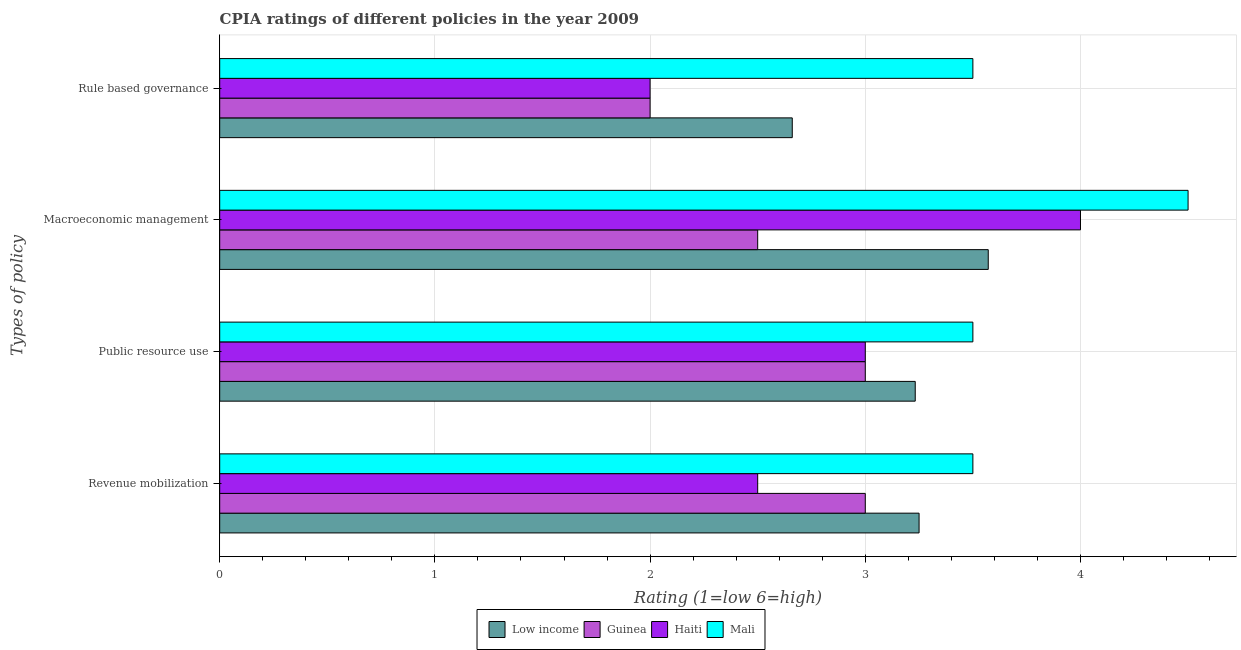How many different coloured bars are there?
Provide a succinct answer. 4. How many bars are there on the 3rd tick from the top?
Give a very brief answer. 4. What is the label of the 2nd group of bars from the top?
Offer a terse response. Macroeconomic management. What is the cpia rating of public resource use in Haiti?
Offer a very short reply. 3. Across all countries, what is the maximum cpia rating of public resource use?
Give a very brief answer. 3.5. Across all countries, what is the minimum cpia rating of public resource use?
Your answer should be compact. 3. In which country was the cpia rating of public resource use maximum?
Provide a succinct answer. Mali. In which country was the cpia rating of public resource use minimum?
Give a very brief answer. Guinea. What is the total cpia rating of rule based governance in the graph?
Offer a terse response. 10.16. What is the difference between the cpia rating of macroeconomic management in Mali and that in Low income?
Provide a succinct answer. 0.93. What is the difference between the cpia rating of public resource use in Low income and the cpia rating of rule based governance in Haiti?
Keep it short and to the point. 1.23. What is the average cpia rating of rule based governance per country?
Your response must be concise. 2.54. What is the difference between the cpia rating of public resource use and cpia rating of revenue mobilization in Low income?
Offer a very short reply. -0.02. In how many countries, is the cpia rating of revenue mobilization greater than 0.6000000000000001 ?
Make the answer very short. 4. What is the ratio of the cpia rating of revenue mobilization in Low income to that in Guinea?
Provide a short and direct response. 1.08. Is the difference between the cpia rating of rule based governance in Guinea and Mali greater than the difference between the cpia rating of revenue mobilization in Guinea and Mali?
Provide a short and direct response. No. What is the difference between the highest and the second highest cpia rating of rule based governance?
Make the answer very short. 0.84. Is it the case that in every country, the sum of the cpia rating of rule based governance and cpia rating of revenue mobilization is greater than the sum of cpia rating of macroeconomic management and cpia rating of public resource use?
Your response must be concise. No. What does the 2nd bar from the top in Rule based governance represents?
Offer a terse response. Haiti. What does the 3rd bar from the bottom in Public resource use represents?
Offer a very short reply. Haiti. Is it the case that in every country, the sum of the cpia rating of revenue mobilization and cpia rating of public resource use is greater than the cpia rating of macroeconomic management?
Provide a succinct answer. Yes. How many bars are there?
Give a very brief answer. 16. What is the difference between two consecutive major ticks on the X-axis?
Keep it short and to the point. 1. Are the values on the major ticks of X-axis written in scientific E-notation?
Offer a terse response. No. Does the graph contain grids?
Offer a terse response. Yes. How many legend labels are there?
Make the answer very short. 4. How are the legend labels stacked?
Keep it short and to the point. Horizontal. What is the title of the graph?
Offer a very short reply. CPIA ratings of different policies in the year 2009. What is the label or title of the Y-axis?
Offer a terse response. Types of policy. What is the Rating (1=low 6=high) in Haiti in Revenue mobilization?
Offer a terse response. 2.5. What is the Rating (1=low 6=high) of Mali in Revenue mobilization?
Ensure brevity in your answer.  3.5. What is the Rating (1=low 6=high) in Low income in Public resource use?
Offer a terse response. 3.23. What is the Rating (1=low 6=high) in Haiti in Public resource use?
Keep it short and to the point. 3. What is the Rating (1=low 6=high) of Low income in Macroeconomic management?
Give a very brief answer. 3.57. What is the Rating (1=low 6=high) in Guinea in Macroeconomic management?
Your response must be concise. 2.5. What is the Rating (1=low 6=high) in Haiti in Macroeconomic management?
Your answer should be very brief. 4. What is the Rating (1=low 6=high) of Mali in Macroeconomic management?
Make the answer very short. 4.5. What is the Rating (1=low 6=high) in Low income in Rule based governance?
Ensure brevity in your answer.  2.66. Across all Types of policy, what is the maximum Rating (1=low 6=high) in Low income?
Offer a terse response. 3.57. Across all Types of policy, what is the maximum Rating (1=low 6=high) in Guinea?
Provide a succinct answer. 3. Across all Types of policy, what is the maximum Rating (1=low 6=high) of Haiti?
Provide a short and direct response. 4. Across all Types of policy, what is the minimum Rating (1=low 6=high) in Low income?
Your answer should be compact. 2.66. Across all Types of policy, what is the minimum Rating (1=low 6=high) of Haiti?
Ensure brevity in your answer.  2. What is the total Rating (1=low 6=high) in Low income in the graph?
Provide a short and direct response. 12.71. What is the total Rating (1=low 6=high) in Haiti in the graph?
Ensure brevity in your answer.  11.5. What is the total Rating (1=low 6=high) in Mali in the graph?
Make the answer very short. 15. What is the difference between the Rating (1=low 6=high) in Low income in Revenue mobilization and that in Public resource use?
Offer a very short reply. 0.02. What is the difference between the Rating (1=low 6=high) of Mali in Revenue mobilization and that in Public resource use?
Your answer should be very brief. 0. What is the difference between the Rating (1=low 6=high) of Low income in Revenue mobilization and that in Macroeconomic management?
Ensure brevity in your answer.  -0.32. What is the difference between the Rating (1=low 6=high) of Guinea in Revenue mobilization and that in Macroeconomic management?
Provide a succinct answer. 0.5. What is the difference between the Rating (1=low 6=high) of Haiti in Revenue mobilization and that in Macroeconomic management?
Ensure brevity in your answer.  -1.5. What is the difference between the Rating (1=low 6=high) of Low income in Revenue mobilization and that in Rule based governance?
Give a very brief answer. 0.59. What is the difference between the Rating (1=low 6=high) in Mali in Revenue mobilization and that in Rule based governance?
Your answer should be very brief. 0. What is the difference between the Rating (1=low 6=high) of Low income in Public resource use and that in Macroeconomic management?
Provide a succinct answer. -0.34. What is the difference between the Rating (1=low 6=high) in Haiti in Public resource use and that in Macroeconomic management?
Ensure brevity in your answer.  -1. What is the difference between the Rating (1=low 6=high) in Mali in Public resource use and that in Macroeconomic management?
Your response must be concise. -1. What is the difference between the Rating (1=low 6=high) in Low income in Public resource use and that in Rule based governance?
Offer a terse response. 0.57. What is the difference between the Rating (1=low 6=high) in Haiti in Public resource use and that in Rule based governance?
Ensure brevity in your answer.  1. What is the difference between the Rating (1=low 6=high) in Low income in Macroeconomic management and that in Rule based governance?
Your answer should be compact. 0.91. What is the difference between the Rating (1=low 6=high) in Guinea in Macroeconomic management and that in Rule based governance?
Provide a succinct answer. 0.5. What is the difference between the Rating (1=low 6=high) in Low income in Revenue mobilization and the Rating (1=low 6=high) in Haiti in Public resource use?
Your response must be concise. 0.25. What is the difference between the Rating (1=low 6=high) in Low income in Revenue mobilization and the Rating (1=low 6=high) in Mali in Public resource use?
Your answer should be compact. -0.25. What is the difference between the Rating (1=low 6=high) in Guinea in Revenue mobilization and the Rating (1=low 6=high) in Mali in Public resource use?
Your response must be concise. -0.5. What is the difference between the Rating (1=low 6=high) in Low income in Revenue mobilization and the Rating (1=low 6=high) in Haiti in Macroeconomic management?
Ensure brevity in your answer.  -0.75. What is the difference between the Rating (1=low 6=high) of Low income in Revenue mobilization and the Rating (1=low 6=high) of Mali in Macroeconomic management?
Keep it short and to the point. -1.25. What is the difference between the Rating (1=low 6=high) of Low income in Revenue mobilization and the Rating (1=low 6=high) of Guinea in Rule based governance?
Your response must be concise. 1.25. What is the difference between the Rating (1=low 6=high) of Low income in Revenue mobilization and the Rating (1=low 6=high) of Haiti in Rule based governance?
Keep it short and to the point. 1.25. What is the difference between the Rating (1=low 6=high) in Guinea in Revenue mobilization and the Rating (1=low 6=high) in Mali in Rule based governance?
Ensure brevity in your answer.  -0.5. What is the difference between the Rating (1=low 6=high) in Low income in Public resource use and the Rating (1=low 6=high) in Guinea in Macroeconomic management?
Offer a terse response. 0.73. What is the difference between the Rating (1=low 6=high) in Low income in Public resource use and the Rating (1=low 6=high) in Haiti in Macroeconomic management?
Your answer should be very brief. -0.77. What is the difference between the Rating (1=low 6=high) of Low income in Public resource use and the Rating (1=low 6=high) of Mali in Macroeconomic management?
Offer a very short reply. -1.27. What is the difference between the Rating (1=low 6=high) in Low income in Public resource use and the Rating (1=low 6=high) in Guinea in Rule based governance?
Give a very brief answer. 1.23. What is the difference between the Rating (1=low 6=high) of Low income in Public resource use and the Rating (1=low 6=high) of Haiti in Rule based governance?
Ensure brevity in your answer.  1.23. What is the difference between the Rating (1=low 6=high) of Low income in Public resource use and the Rating (1=low 6=high) of Mali in Rule based governance?
Make the answer very short. -0.27. What is the difference between the Rating (1=low 6=high) of Guinea in Public resource use and the Rating (1=low 6=high) of Haiti in Rule based governance?
Offer a terse response. 1. What is the difference between the Rating (1=low 6=high) of Haiti in Public resource use and the Rating (1=low 6=high) of Mali in Rule based governance?
Your answer should be very brief. -0.5. What is the difference between the Rating (1=low 6=high) of Low income in Macroeconomic management and the Rating (1=low 6=high) of Guinea in Rule based governance?
Offer a very short reply. 1.57. What is the difference between the Rating (1=low 6=high) of Low income in Macroeconomic management and the Rating (1=low 6=high) of Haiti in Rule based governance?
Make the answer very short. 1.57. What is the difference between the Rating (1=low 6=high) in Low income in Macroeconomic management and the Rating (1=low 6=high) in Mali in Rule based governance?
Keep it short and to the point. 0.07. What is the difference between the Rating (1=low 6=high) of Guinea in Macroeconomic management and the Rating (1=low 6=high) of Haiti in Rule based governance?
Make the answer very short. 0.5. What is the difference between the Rating (1=low 6=high) of Guinea in Macroeconomic management and the Rating (1=low 6=high) of Mali in Rule based governance?
Keep it short and to the point. -1. What is the average Rating (1=low 6=high) in Low income per Types of policy?
Keep it short and to the point. 3.18. What is the average Rating (1=low 6=high) of Guinea per Types of policy?
Provide a succinct answer. 2.62. What is the average Rating (1=low 6=high) in Haiti per Types of policy?
Your response must be concise. 2.88. What is the average Rating (1=low 6=high) of Mali per Types of policy?
Your answer should be very brief. 3.75. What is the difference between the Rating (1=low 6=high) of Low income and Rating (1=low 6=high) of Guinea in Revenue mobilization?
Your answer should be compact. 0.25. What is the difference between the Rating (1=low 6=high) of Guinea and Rating (1=low 6=high) of Haiti in Revenue mobilization?
Your answer should be compact. 0.5. What is the difference between the Rating (1=low 6=high) of Low income and Rating (1=low 6=high) of Guinea in Public resource use?
Give a very brief answer. 0.23. What is the difference between the Rating (1=low 6=high) in Low income and Rating (1=low 6=high) in Haiti in Public resource use?
Make the answer very short. 0.23. What is the difference between the Rating (1=low 6=high) of Low income and Rating (1=low 6=high) of Mali in Public resource use?
Offer a very short reply. -0.27. What is the difference between the Rating (1=low 6=high) in Guinea and Rating (1=low 6=high) in Haiti in Public resource use?
Keep it short and to the point. 0. What is the difference between the Rating (1=low 6=high) in Guinea and Rating (1=low 6=high) in Mali in Public resource use?
Your answer should be very brief. -0.5. What is the difference between the Rating (1=low 6=high) in Haiti and Rating (1=low 6=high) in Mali in Public resource use?
Your answer should be compact. -0.5. What is the difference between the Rating (1=low 6=high) of Low income and Rating (1=low 6=high) of Guinea in Macroeconomic management?
Provide a succinct answer. 1.07. What is the difference between the Rating (1=low 6=high) of Low income and Rating (1=low 6=high) of Haiti in Macroeconomic management?
Keep it short and to the point. -0.43. What is the difference between the Rating (1=low 6=high) in Low income and Rating (1=low 6=high) in Mali in Macroeconomic management?
Give a very brief answer. -0.93. What is the difference between the Rating (1=low 6=high) in Guinea and Rating (1=low 6=high) in Haiti in Macroeconomic management?
Offer a terse response. -1.5. What is the difference between the Rating (1=low 6=high) of Guinea and Rating (1=low 6=high) of Mali in Macroeconomic management?
Provide a succinct answer. -2. What is the difference between the Rating (1=low 6=high) of Low income and Rating (1=low 6=high) of Guinea in Rule based governance?
Offer a terse response. 0.66. What is the difference between the Rating (1=low 6=high) in Low income and Rating (1=low 6=high) in Haiti in Rule based governance?
Ensure brevity in your answer.  0.66. What is the difference between the Rating (1=low 6=high) in Low income and Rating (1=low 6=high) in Mali in Rule based governance?
Give a very brief answer. -0.84. What is the ratio of the Rating (1=low 6=high) of Low income in Revenue mobilization to that in Public resource use?
Make the answer very short. 1.01. What is the ratio of the Rating (1=low 6=high) of Guinea in Revenue mobilization to that in Public resource use?
Ensure brevity in your answer.  1. What is the ratio of the Rating (1=low 6=high) in Haiti in Revenue mobilization to that in Public resource use?
Give a very brief answer. 0.83. What is the ratio of the Rating (1=low 6=high) in Low income in Revenue mobilization to that in Macroeconomic management?
Your answer should be very brief. 0.91. What is the ratio of the Rating (1=low 6=high) in Guinea in Revenue mobilization to that in Macroeconomic management?
Provide a short and direct response. 1.2. What is the ratio of the Rating (1=low 6=high) in Mali in Revenue mobilization to that in Macroeconomic management?
Your answer should be very brief. 0.78. What is the ratio of the Rating (1=low 6=high) in Low income in Revenue mobilization to that in Rule based governance?
Offer a very short reply. 1.22. What is the ratio of the Rating (1=low 6=high) in Mali in Revenue mobilization to that in Rule based governance?
Your answer should be very brief. 1. What is the ratio of the Rating (1=low 6=high) of Low income in Public resource use to that in Macroeconomic management?
Your response must be concise. 0.91. What is the ratio of the Rating (1=low 6=high) of Haiti in Public resource use to that in Macroeconomic management?
Make the answer very short. 0.75. What is the ratio of the Rating (1=low 6=high) in Low income in Public resource use to that in Rule based governance?
Your response must be concise. 1.21. What is the ratio of the Rating (1=low 6=high) of Guinea in Public resource use to that in Rule based governance?
Provide a short and direct response. 1.5. What is the ratio of the Rating (1=low 6=high) of Haiti in Public resource use to that in Rule based governance?
Make the answer very short. 1.5. What is the ratio of the Rating (1=low 6=high) of Mali in Public resource use to that in Rule based governance?
Offer a terse response. 1. What is the ratio of the Rating (1=low 6=high) of Low income in Macroeconomic management to that in Rule based governance?
Your answer should be very brief. 1.34. What is the ratio of the Rating (1=low 6=high) of Guinea in Macroeconomic management to that in Rule based governance?
Provide a succinct answer. 1.25. What is the ratio of the Rating (1=low 6=high) in Mali in Macroeconomic management to that in Rule based governance?
Provide a succinct answer. 1.29. What is the difference between the highest and the second highest Rating (1=low 6=high) in Low income?
Provide a succinct answer. 0.32. What is the difference between the highest and the second highest Rating (1=low 6=high) in Haiti?
Offer a very short reply. 1. What is the difference between the highest and the lowest Rating (1=low 6=high) of Low income?
Your response must be concise. 0.91. What is the difference between the highest and the lowest Rating (1=low 6=high) of Guinea?
Provide a short and direct response. 1. What is the difference between the highest and the lowest Rating (1=low 6=high) of Haiti?
Offer a terse response. 2. What is the difference between the highest and the lowest Rating (1=low 6=high) of Mali?
Your answer should be compact. 1. 